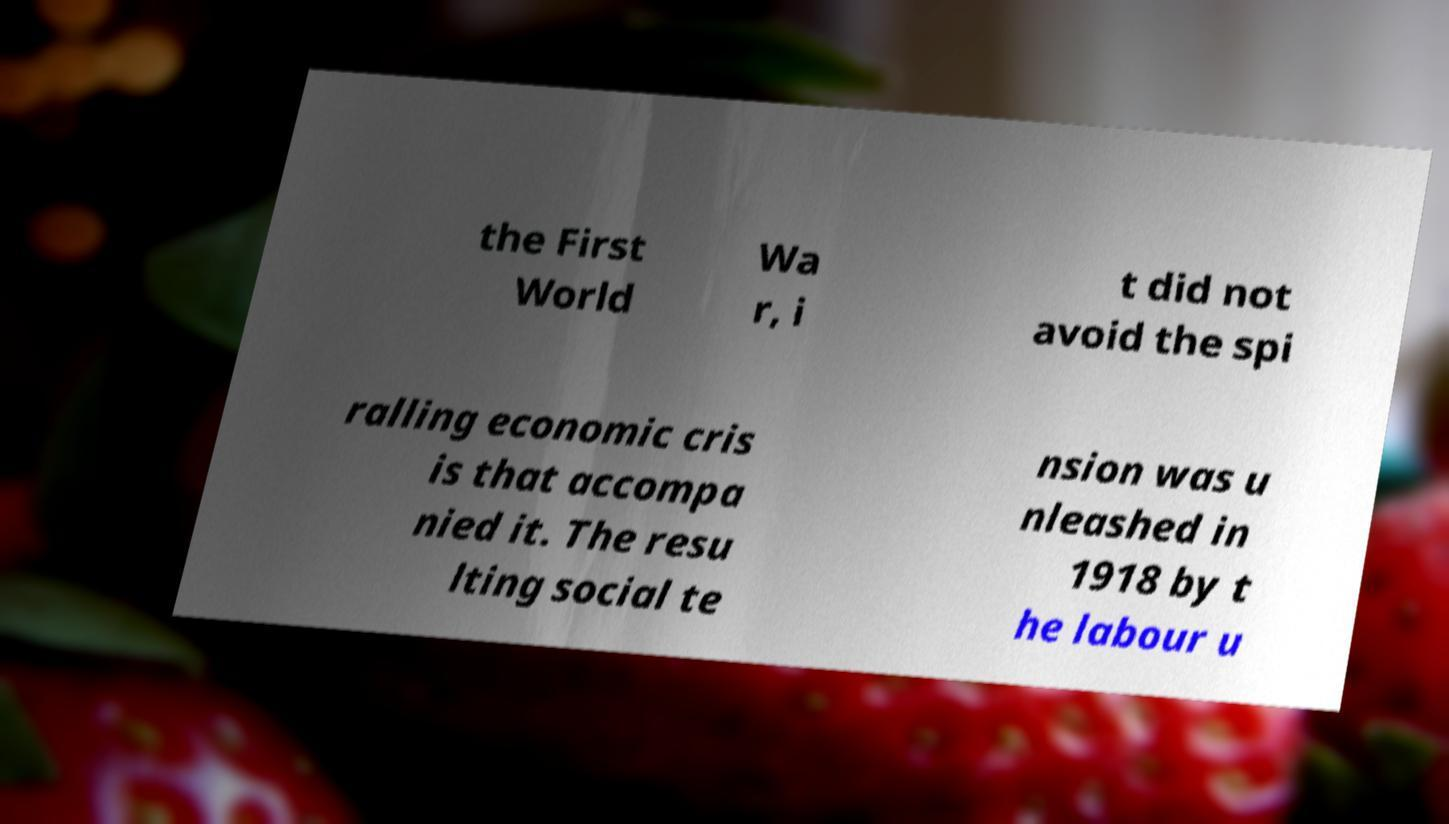What messages or text are displayed in this image? I need them in a readable, typed format. the First World Wa r, i t did not avoid the spi ralling economic cris is that accompa nied it. The resu lting social te nsion was u nleashed in 1918 by t he labour u 